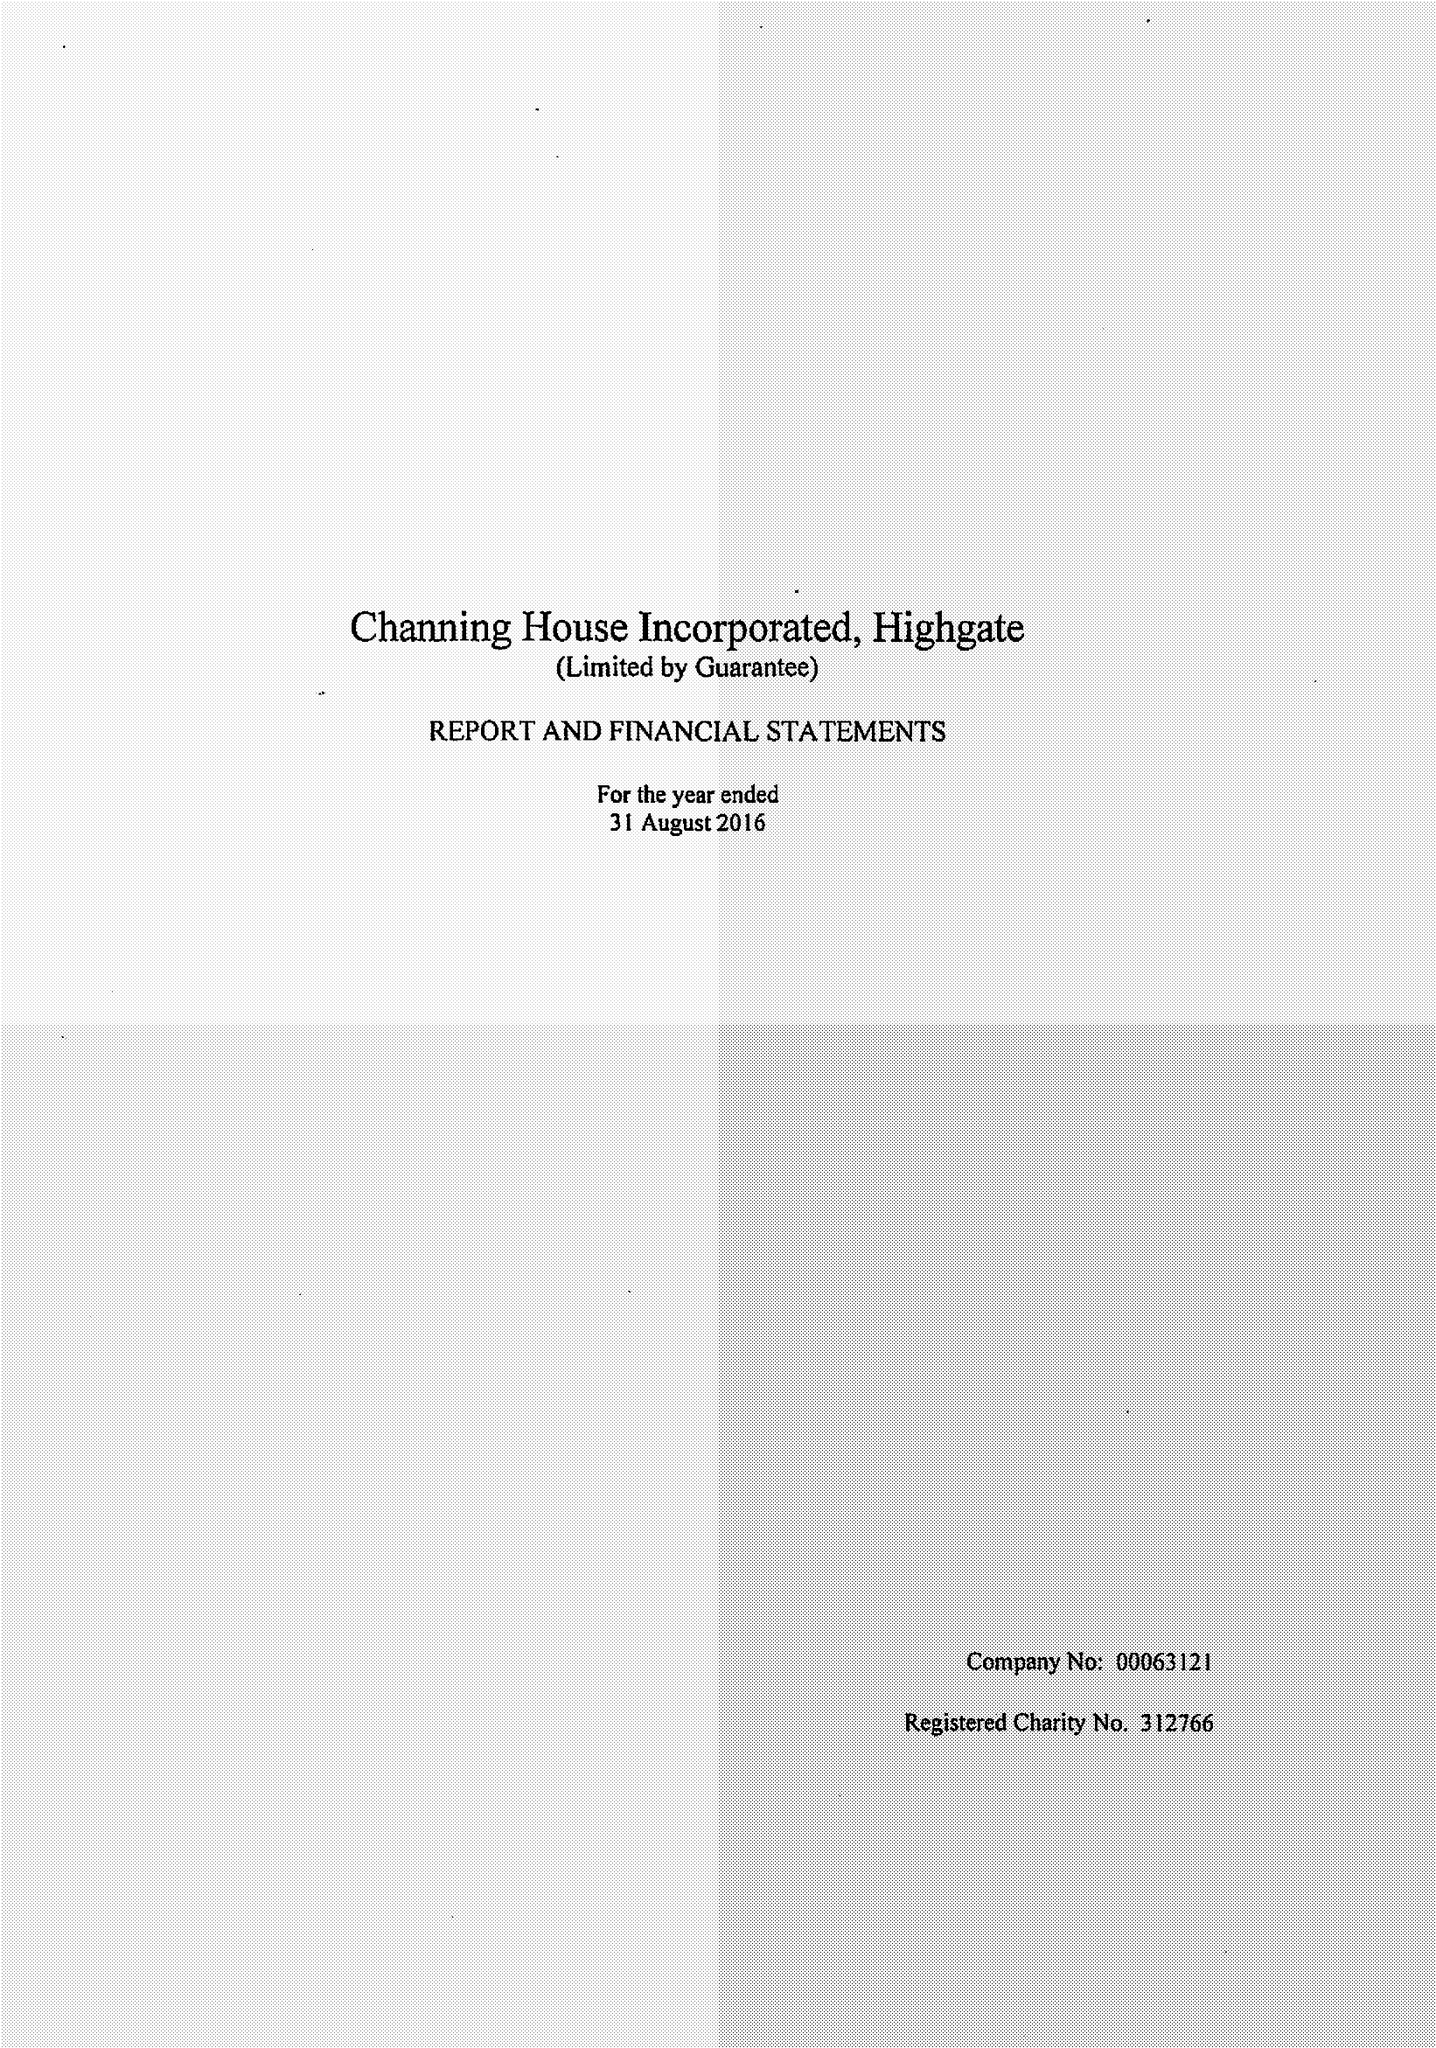What is the value for the address__street_line?
Answer the question using a single word or phrase. HIGHGATE HILL 